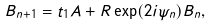Convert formula to latex. <formula><loc_0><loc_0><loc_500><loc_500>B _ { n + 1 } = t _ { 1 } A + R \exp ( 2 i \psi _ { n } ) B _ { n } ,</formula> 